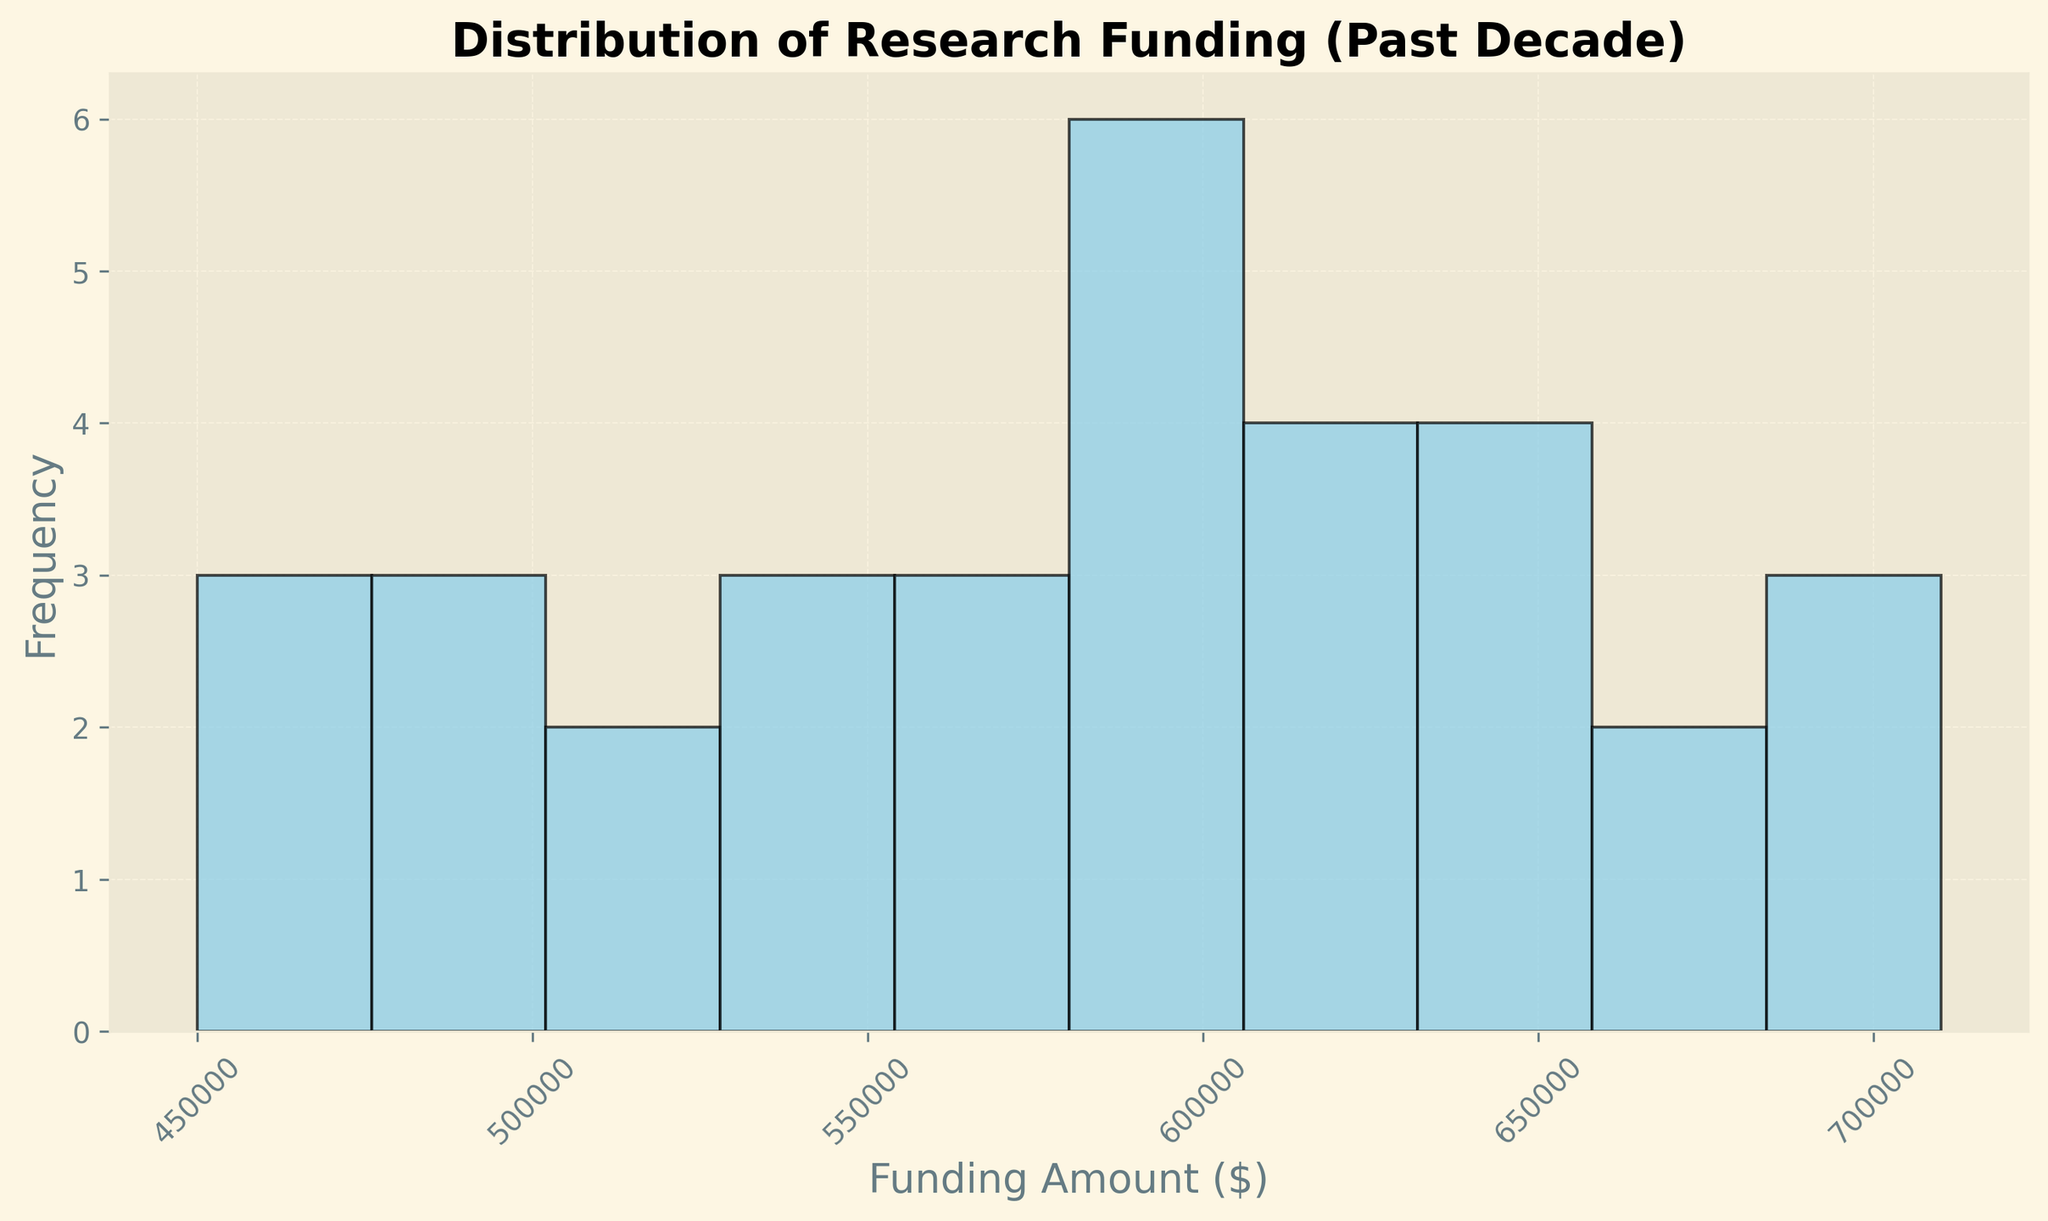What is the most common funding range for interdisciplinary projects over the past decade? First, look at the histogram to identify which bins have the highest frequency. The bar that is tallest represents the most common funding range.
Answer: The most common funding range is the bin corresponding to the highest bar What is the highest funding amount depicted in the histogram? Locate the rightmost edge of the histogram to find the highest funding amount. This will be the upper limit of the last bin.
Answer: $710,000 Which funding range has the lowest frequency of projects? Look for the shortest bar in the histogram as it represents the funding range with the fewest projects.
Answer: The funding range represented by the shortest bar How many projects received funding between $450,000 and $500,000? Identify and count the number of bins between $450,000 and $500,000 and check the height (frequency) of those bins.
Answer: The number of projects that fall into the bins from $450,000 to $500,000 What is the difference in frequency between the bins corresponding to $600,000 and $650,000? Find the height of the bars for $600,000 and $650,000 bins. Subtract the shorter bar's height from the taller bar's height to get the difference in frequency.
Answer: The difference in frequency between the two bins Which funding range appears to capture the median funding amount? Determine the bin that divides the data into two equal halves, meaning half the data falls below this range and half falls above it. This is typically the bin at the 50th percentile.
Answer: The bin representing the median funding amount How would you describe the spread of funding across projects? Is the distribution skewed or symmetric? Observe the shape of the histogram, including the symmetry and tails of the bars. Determine if there's a long tail on one side or if both sides mirror each other.
Answer: Description of the spread, indicating if it is skewed left, right, or symmetric What is the average funding amount for the projects, and how does it compare to the median? Calculate the mean by summing all funding amounts and dividing by the number of projects. Compare this value to the median by identifying which bin captures the median.
Answer: The average funding amount and its comparison to the median value Which categories of projects (listed in the data) fall in the funding range where most projects received funding? Identify the most common funding range from the histogram, then cross-reference this with the data provided to list the projects falling into this range.
Answer: Categories of projects in the most common funding range 